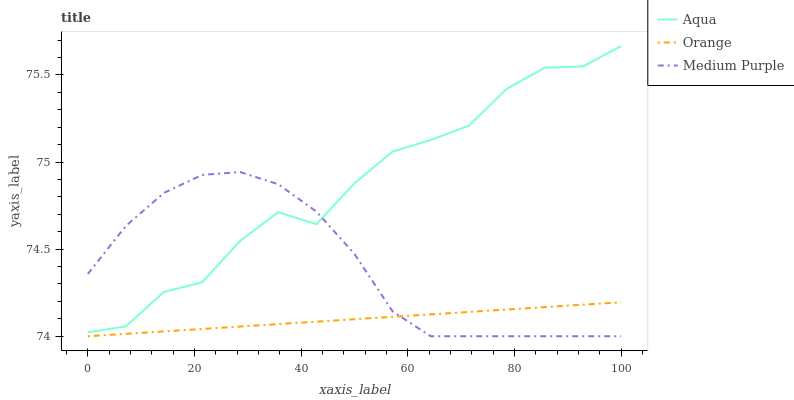Does Orange have the minimum area under the curve?
Answer yes or no. Yes. Does Aqua have the maximum area under the curve?
Answer yes or no. Yes. Does Medium Purple have the minimum area under the curve?
Answer yes or no. No. Does Medium Purple have the maximum area under the curve?
Answer yes or no. No. Is Orange the smoothest?
Answer yes or no. Yes. Is Aqua the roughest?
Answer yes or no. Yes. Is Medium Purple the smoothest?
Answer yes or no. No. Is Medium Purple the roughest?
Answer yes or no. No. Does Orange have the lowest value?
Answer yes or no. Yes. Does Aqua have the lowest value?
Answer yes or no. No. Does Aqua have the highest value?
Answer yes or no. Yes. Does Medium Purple have the highest value?
Answer yes or no. No. Is Orange less than Aqua?
Answer yes or no. Yes. Is Aqua greater than Orange?
Answer yes or no. Yes. Does Orange intersect Medium Purple?
Answer yes or no. Yes. Is Orange less than Medium Purple?
Answer yes or no. No. Is Orange greater than Medium Purple?
Answer yes or no. No. Does Orange intersect Aqua?
Answer yes or no. No. 